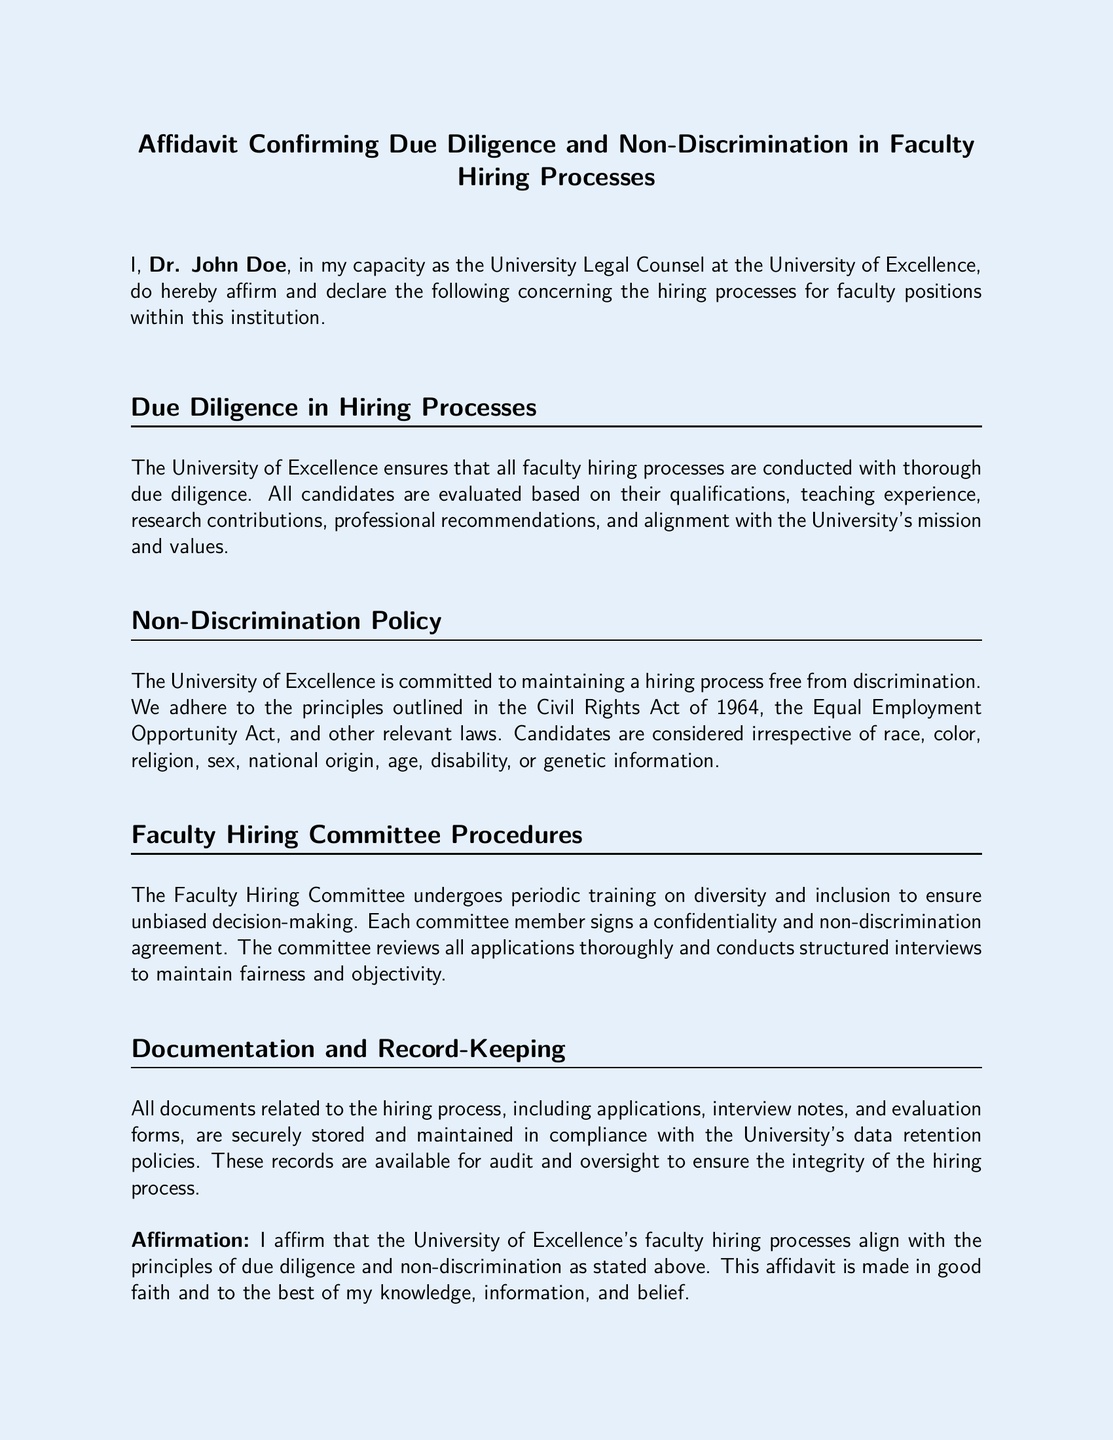What is the name of the affiant? The affiant is the individual who signs the affidavit, in this case, it is Dr. John Doe.
Answer: Dr. John Doe What is the position of the affiant? The position of the affiant is indicated in the document, specifically mentioned as University Legal Counsel.
Answer: University Legal Counsel What date was the affidavit signed? The date is explicitly stated in the document as the signing date, which is October 11, 2023.
Answer: October 11, 2023 What commitment does the University of Excellence follow according to the affidavit? The document states the commitment to maintain a hiring process free from discrimination as detailed in the non-discrimination policy.
Answer: Free from discrimination Which act is mentioned in the non-discrimination policy? The Civil Rights Act of 1964 is referenced as a foundational legislation ensuring non-discrimination in hiring practices.
Answer: Civil Rights Act of 1964 What type of training does the Faculty Hiring Committee undergo? The affidavit mentions that the Faculty Hiring Committee undergoes training specifically on diversity and inclusion.
Answer: Diversity and inclusion What is stated about the confidentiality agreements? The document indicates that each committee member signs a confidentiality and non-discrimination agreement.
Answer: Confidentiality and non-discrimination agreement Where is the University of Excellence located? The place is identified in the document as Knowledge City, Education State.
Answer: Knowledge City, Education State What type of documentation is maintained according to the affidavit? The document specifies that all documents related to the hiring process, such as applications, interview notes, and evaluation forms, are maintained and securely stored.
Answer: Applications, interview notes, evaluation forms 